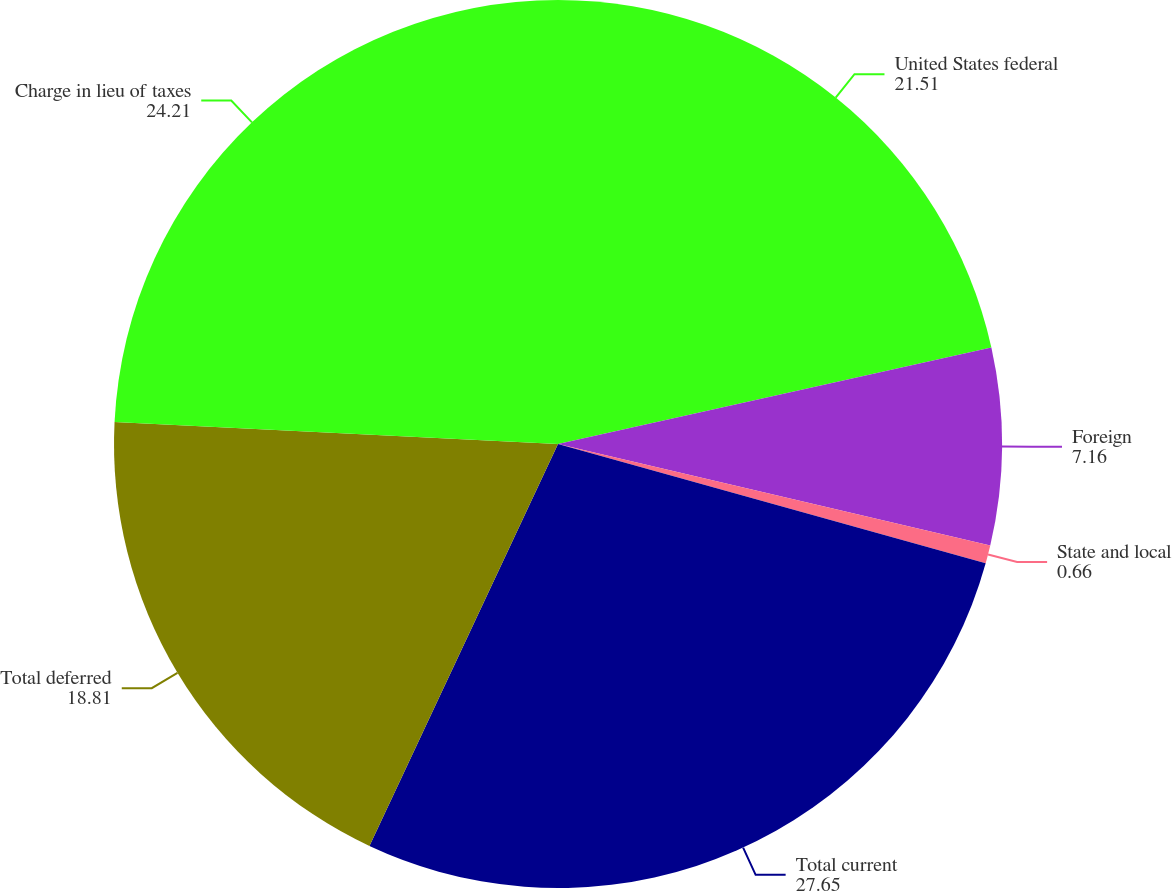Convert chart to OTSL. <chart><loc_0><loc_0><loc_500><loc_500><pie_chart><fcel>United States federal<fcel>Foreign<fcel>State and local<fcel>Total current<fcel>Total deferred<fcel>Charge in lieu of taxes<nl><fcel>21.51%<fcel>7.16%<fcel>0.66%<fcel>27.65%<fcel>18.81%<fcel>24.21%<nl></chart> 